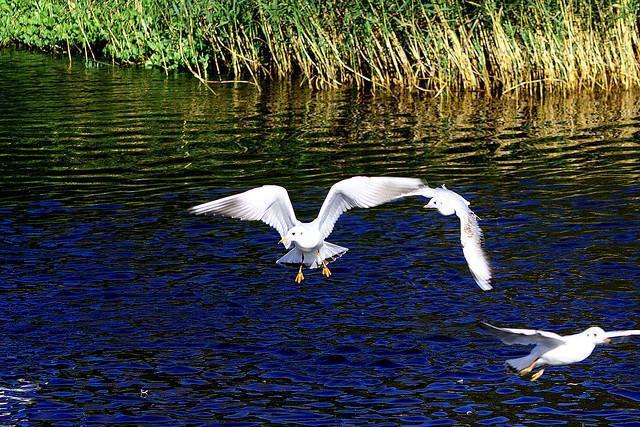How many white birds are flying?
Give a very brief answer. 3. How many birds are in the picture?
Give a very brief answer. 3. How many people are in the picture?
Give a very brief answer. 0. 